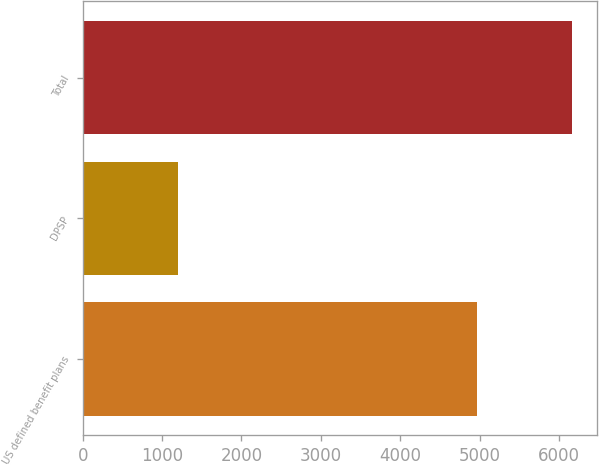<chart> <loc_0><loc_0><loc_500><loc_500><bar_chart><fcel>US defined benefit plans<fcel>DPSP<fcel>Total<nl><fcel>4970<fcel>1197<fcel>6167<nl></chart> 